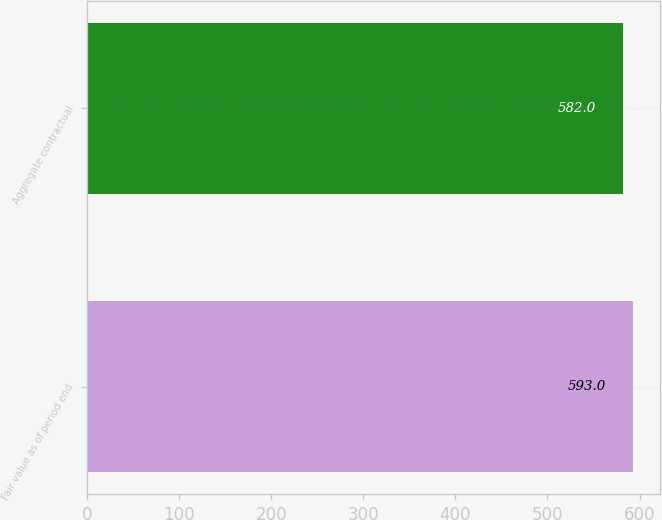<chart> <loc_0><loc_0><loc_500><loc_500><bar_chart><fcel>Fair value as of period end<fcel>Aggregate contractual<nl><fcel>593<fcel>582<nl></chart> 